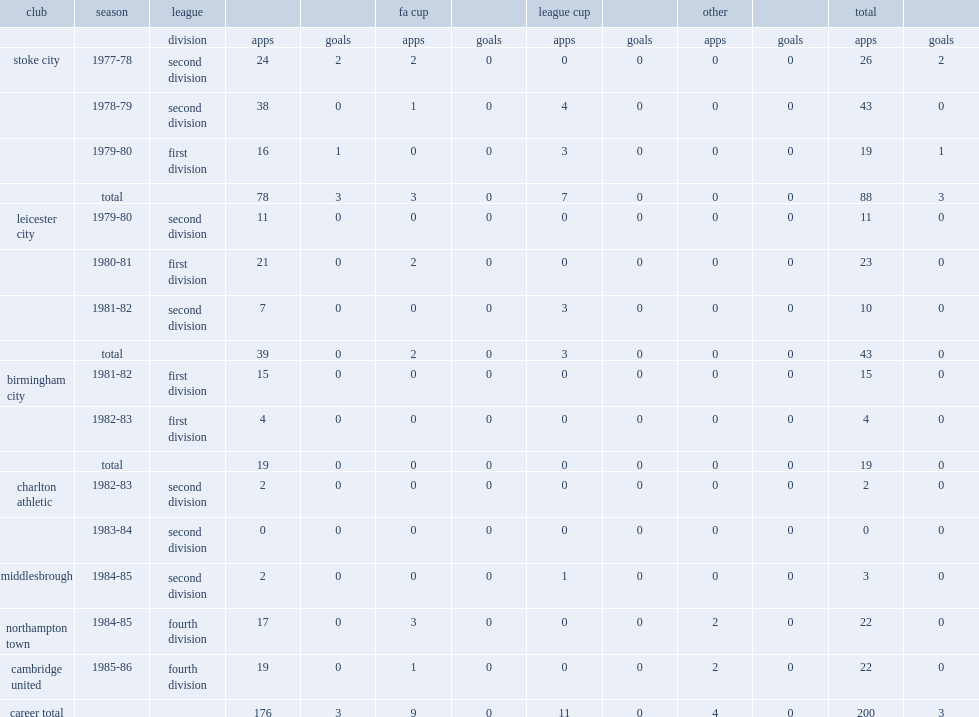How many appearances did geoffrey scott make for stoke city, leicester city, birmingham city, charlton athletic, middlesbrough, northampton town and cambridge united? 176.0. 